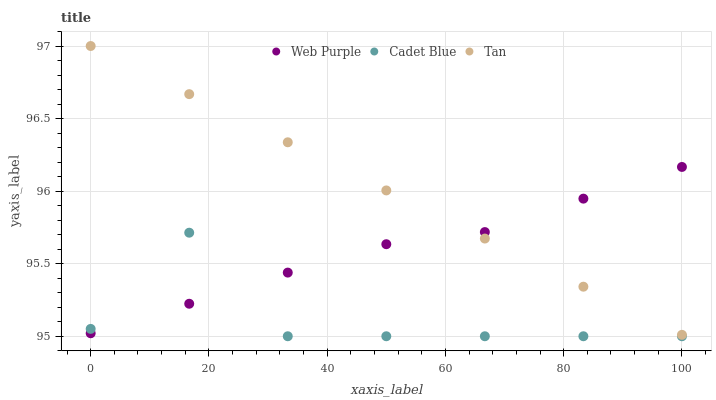Does Cadet Blue have the minimum area under the curve?
Answer yes or no. Yes. Does Tan have the maximum area under the curve?
Answer yes or no. Yes. Does Tan have the minimum area under the curve?
Answer yes or no. No. Does Cadet Blue have the maximum area under the curve?
Answer yes or no. No. Is Tan the smoothest?
Answer yes or no. Yes. Is Cadet Blue the roughest?
Answer yes or no. Yes. Is Cadet Blue the smoothest?
Answer yes or no. No. Is Tan the roughest?
Answer yes or no. No. Does Cadet Blue have the lowest value?
Answer yes or no. Yes. Does Tan have the lowest value?
Answer yes or no. No. Does Tan have the highest value?
Answer yes or no. Yes. Does Cadet Blue have the highest value?
Answer yes or no. No. Is Cadet Blue less than Tan?
Answer yes or no. Yes. Is Tan greater than Cadet Blue?
Answer yes or no. Yes. Does Web Purple intersect Cadet Blue?
Answer yes or no. Yes. Is Web Purple less than Cadet Blue?
Answer yes or no. No. Is Web Purple greater than Cadet Blue?
Answer yes or no. No. Does Cadet Blue intersect Tan?
Answer yes or no. No. 